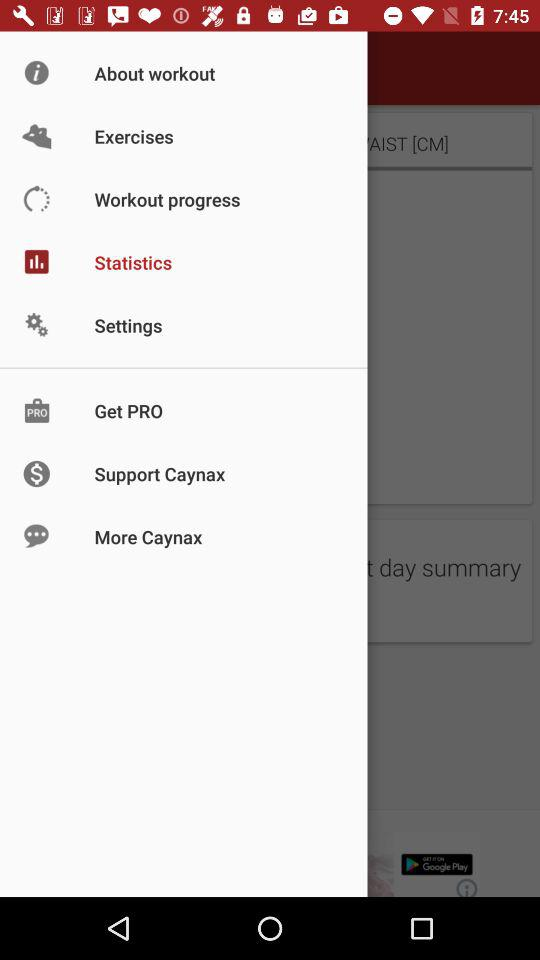Which item is selected in the menu? The selected item is "Statistics". 